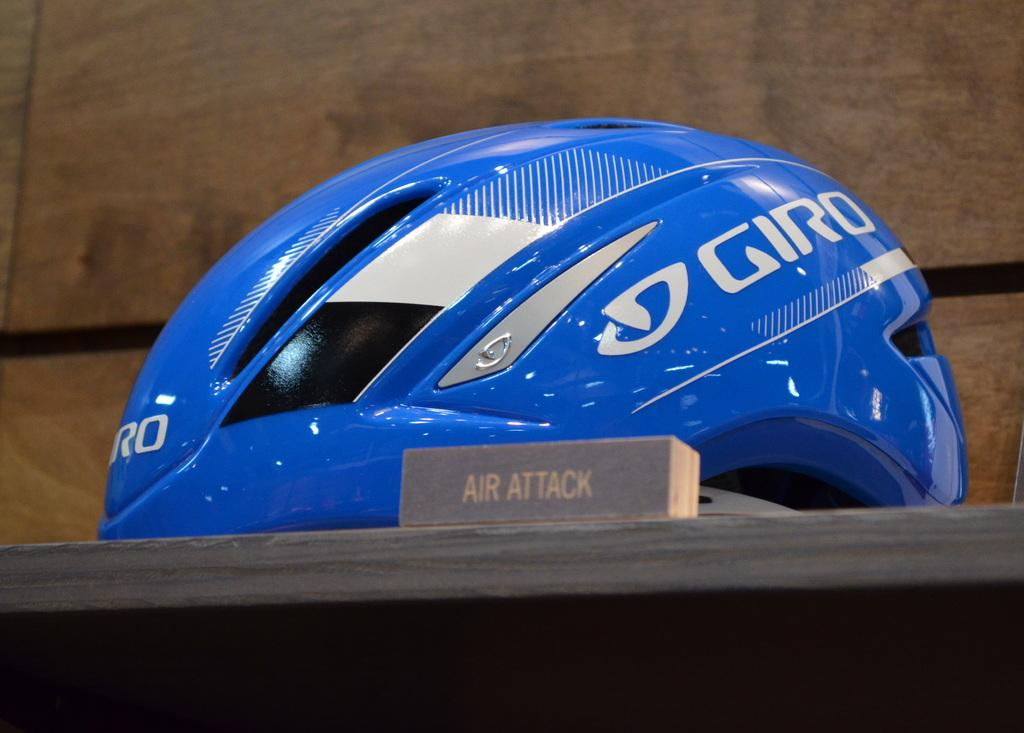What object can be seen in the image? There is a helmet in the image. What is the color of the helmet? The helmet is blue in color. What type of trains can be seen in the image? There are no trains present in the image; it only features a blue helmet. How does the person wearing the helmet express anger in the image? There is no person wearing the helmet or expressing anger in the image, as it only shows the helmet itself. 